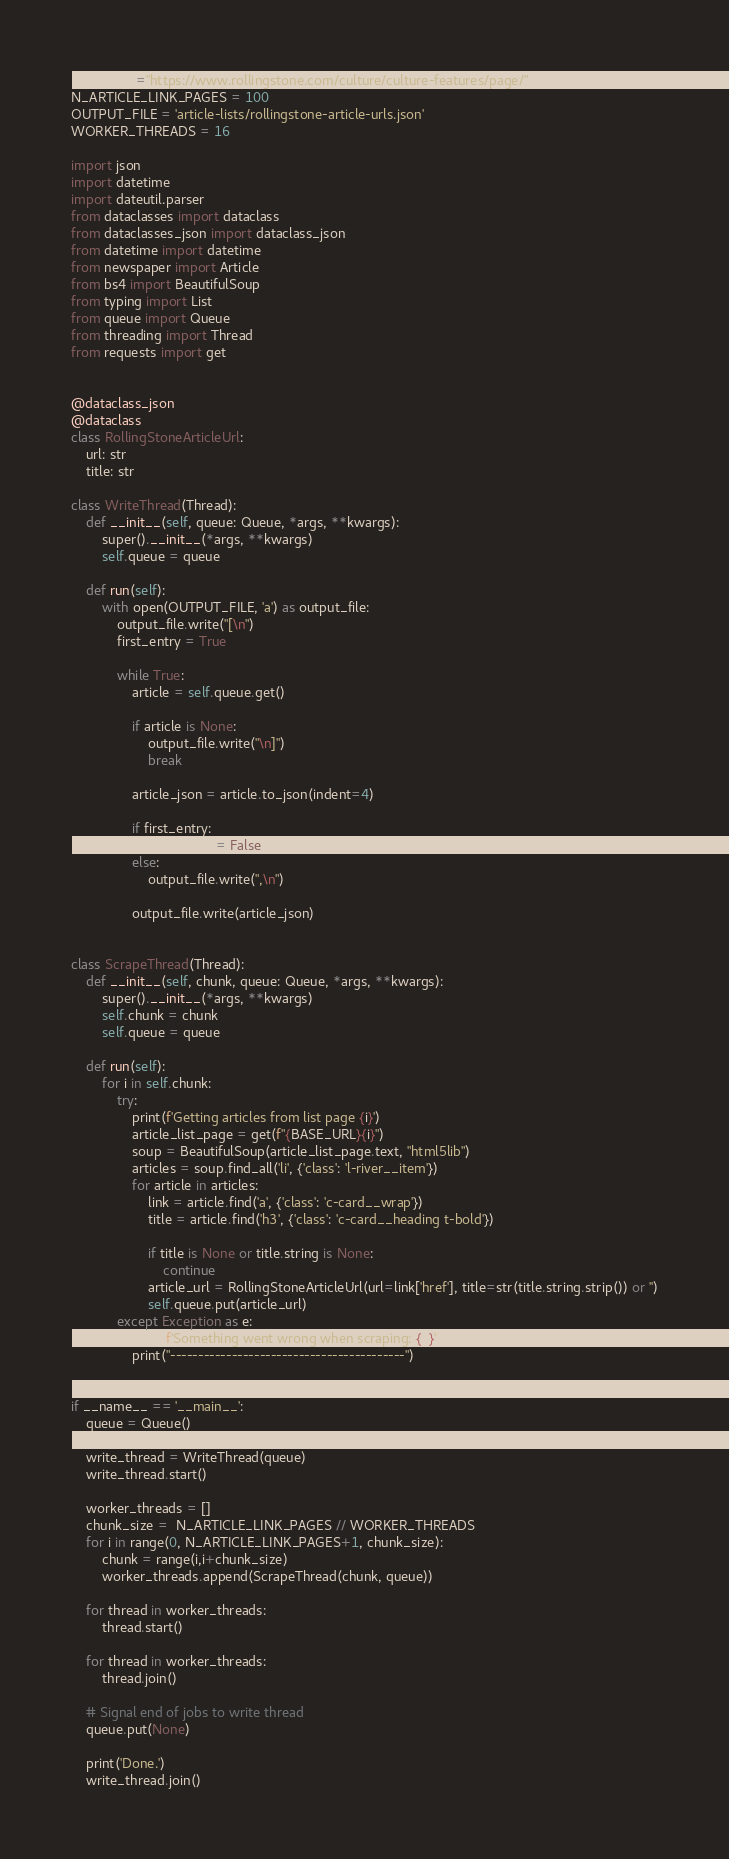<code> <loc_0><loc_0><loc_500><loc_500><_Python_>BASE_URL="https://www.rollingstone.com/culture/culture-features/page/"
N_ARTICLE_LINK_PAGES = 100
OUTPUT_FILE = 'article-lists/rollingstone-article-urls.json'
WORKER_THREADS = 16

import json
import datetime
import dateutil.parser
from dataclasses import dataclass
from dataclasses_json import dataclass_json
from datetime import datetime
from newspaper import Article
from bs4 import BeautifulSoup
from typing import List
from queue import Queue
from threading import Thread
from requests import get


@dataclass_json
@dataclass
class RollingStoneArticleUrl:
    url: str
    title: str

class WriteThread(Thread):
    def __init__(self, queue: Queue, *args, **kwargs):
        super().__init__(*args, **kwargs)
        self.queue = queue

    def run(self):
        with open(OUTPUT_FILE, 'a') as output_file:
            output_file.write("[\n")
            first_entry = True

            while True:
                article = self.queue.get()

                if article is None:
                    output_file.write("\n]")
                    break

                article_json = article.to_json(indent=4)

                if first_entry:
                    first_entry = False
                else:
                    output_file.write(",\n")

                output_file.write(article_json)


class ScrapeThread(Thread):
    def __init__(self, chunk, queue: Queue, *args, **kwargs):
        super().__init__(*args, **kwargs)
        self.chunk = chunk
        self.queue = queue

    def run(self):
        for i in self.chunk:
            try:
                print(f'Getting articles from list page {i}')
                article_list_page = get(f"{BASE_URL}{i}")
                soup = BeautifulSoup(article_list_page.text, "html5lib")
                articles = soup.find_all('li', {'class': 'l-river__item'})
                for article in articles: 
                    link = article.find('a', {'class': 'c-card__wrap'})
                    title = article.find('h3', {'class': 'c-card__heading t-bold'})
        
                    if title is None or title.string is None:
                        continue
                    article_url = RollingStoneArticleUrl(url=link['href'], title=str(title.string.strip()) or '')
                    self.queue.put(article_url)
            except Exception as e:
                print(f'Something went wrong when scraping: {e}')
                print("------------------------------------------")


if __name__ == '__main__':
    queue = Queue()

    write_thread = WriteThread(queue)
    write_thread.start()

    worker_threads = []
    chunk_size =  N_ARTICLE_LINK_PAGES // WORKER_THREADS
    for i in range(0, N_ARTICLE_LINK_PAGES+1, chunk_size):
        chunk = range(i,i+chunk_size)
        worker_threads.append(ScrapeThread(chunk, queue))

    for thread in worker_threads:
        thread.start()

    for thread in worker_threads:
        thread.join()

    # Signal end of jobs to write thread
    queue.put(None)

    print('Done.')
    write_thread.join()</code> 